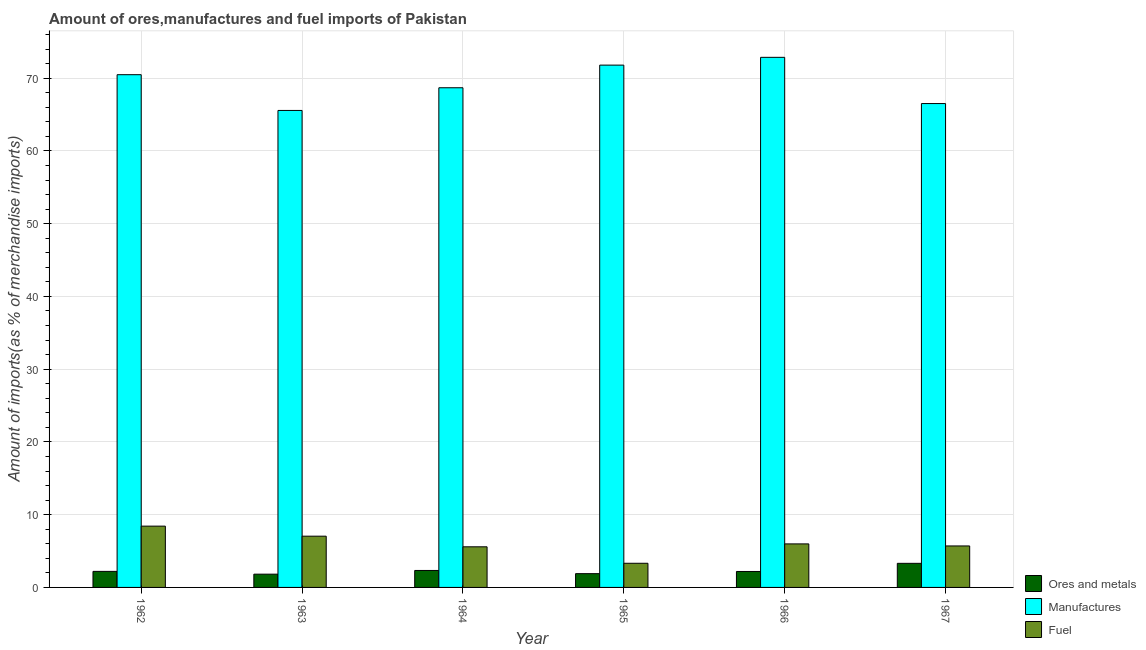How many groups of bars are there?
Your response must be concise. 6. Are the number of bars on each tick of the X-axis equal?
Your response must be concise. Yes. How many bars are there on the 2nd tick from the left?
Keep it short and to the point. 3. What is the label of the 6th group of bars from the left?
Provide a succinct answer. 1967. What is the percentage of ores and metals imports in 1967?
Offer a very short reply. 3.31. Across all years, what is the maximum percentage of fuel imports?
Offer a very short reply. 8.43. Across all years, what is the minimum percentage of ores and metals imports?
Provide a short and direct response. 1.82. In which year was the percentage of manufactures imports maximum?
Offer a terse response. 1966. What is the total percentage of ores and metals imports in the graph?
Offer a very short reply. 13.76. What is the difference between the percentage of manufactures imports in 1964 and that in 1966?
Provide a succinct answer. -4.18. What is the difference between the percentage of manufactures imports in 1963 and the percentage of ores and metals imports in 1966?
Your answer should be compact. -7.3. What is the average percentage of ores and metals imports per year?
Provide a succinct answer. 2.29. In how many years, is the percentage of ores and metals imports greater than 30 %?
Provide a short and direct response. 0. What is the ratio of the percentage of manufactures imports in 1964 to that in 1966?
Provide a short and direct response. 0.94. Is the percentage of fuel imports in 1966 less than that in 1967?
Your answer should be compact. No. What is the difference between the highest and the second highest percentage of manufactures imports?
Keep it short and to the point. 1.07. What is the difference between the highest and the lowest percentage of manufactures imports?
Your answer should be compact. 7.3. What does the 2nd bar from the left in 1963 represents?
Keep it short and to the point. Manufactures. What does the 1st bar from the right in 1963 represents?
Offer a terse response. Fuel. Is it the case that in every year, the sum of the percentage of ores and metals imports and percentage of manufactures imports is greater than the percentage of fuel imports?
Provide a short and direct response. Yes. Are all the bars in the graph horizontal?
Offer a very short reply. No. How many years are there in the graph?
Your answer should be compact. 6. Are the values on the major ticks of Y-axis written in scientific E-notation?
Provide a short and direct response. No. Does the graph contain any zero values?
Your answer should be compact. No. How are the legend labels stacked?
Your response must be concise. Vertical. What is the title of the graph?
Provide a short and direct response. Amount of ores,manufactures and fuel imports of Pakistan. Does "Domestic" appear as one of the legend labels in the graph?
Your response must be concise. No. What is the label or title of the Y-axis?
Your answer should be very brief. Amount of imports(as % of merchandise imports). What is the Amount of imports(as % of merchandise imports) in Ores and metals in 1962?
Offer a very short reply. 2.21. What is the Amount of imports(as % of merchandise imports) in Manufactures in 1962?
Make the answer very short. 70.48. What is the Amount of imports(as % of merchandise imports) of Fuel in 1962?
Your response must be concise. 8.43. What is the Amount of imports(as % of merchandise imports) of Ores and metals in 1963?
Your answer should be very brief. 1.82. What is the Amount of imports(as % of merchandise imports) of Manufactures in 1963?
Make the answer very short. 65.57. What is the Amount of imports(as % of merchandise imports) of Fuel in 1963?
Your response must be concise. 7.04. What is the Amount of imports(as % of merchandise imports) in Ores and metals in 1964?
Make the answer very short. 2.33. What is the Amount of imports(as % of merchandise imports) in Manufactures in 1964?
Make the answer very short. 68.68. What is the Amount of imports(as % of merchandise imports) in Fuel in 1964?
Make the answer very short. 5.58. What is the Amount of imports(as % of merchandise imports) of Ores and metals in 1965?
Your answer should be very brief. 1.89. What is the Amount of imports(as % of merchandise imports) of Manufactures in 1965?
Your response must be concise. 71.79. What is the Amount of imports(as % of merchandise imports) of Fuel in 1965?
Give a very brief answer. 3.32. What is the Amount of imports(as % of merchandise imports) of Ores and metals in 1966?
Your answer should be compact. 2.19. What is the Amount of imports(as % of merchandise imports) in Manufactures in 1966?
Offer a very short reply. 72.87. What is the Amount of imports(as % of merchandise imports) of Fuel in 1966?
Offer a terse response. 5.98. What is the Amount of imports(as % of merchandise imports) of Ores and metals in 1967?
Your response must be concise. 3.31. What is the Amount of imports(as % of merchandise imports) in Manufactures in 1967?
Your answer should be compact. 66.51. What is the Amount of imports(as % of merchandise imports) of Fuel in 1967?
Your answer should be very brief. 5.7. Across all years, what is the maximum Amount of imports(as % of merchandise imports) of Ores and metals?
Ensure brevity in your answer.  3.31. Across all years, what is the maximum Amount of imports(as % of merchandise imports) of Manufactures?
Make the answer very short. 72.87. Across all years, what is the maximum Amount of imports(as % of merchandise imports) in Fuel?
Your answer should be compact. 8.43. Across all years, what is the minimum Amount of imports(as % of merchandise imports) of Ores and metals?
Offer a very short reply. 1.82. Across all years, what is the minimum Amount of imports(as % of merchandise imports) in Manufactures?
Give a very brief answer. 65.57. Across all years, what is the minimum Amount of imports(as % of merchandise imports) in Fuel?
Your answer should be compact. 3.32. What is the total Amount of imports(as % of merchandise imports) in Ores and metals in the graph?
Offer a terse response. 13.76. What is the total Amount of imports(as % of merchandise imports) of Manufactures in the graph?
Provide a short and direct response. 415.9. What is the total Amount of imports(as % of merchandise imports) of Fuel in the graph?
Offer a very short reply. 36.06. What is the difference between the Amount of imports(as % of merchandise imports) in Ores and metals in 1962 and that in 1963?
Keep it short and to the point. 0.38. What is the difference between the Amount of imports(as % of merchandise imports) in Manufactures in 1962 and that in 1963?
Make the answer very short. 4.91. What is the difference between the Amount of imports(as % of merchandise imports) in Fuel in 1962 and that in 1963?
Provide a short and direct response. 1.38. What is the difference between the Amount of imports(as % of merchandise imports) in Ores and metals in 1962 and that in 1964?
Give a very brief answer. -0.13. What is the difference between the Amount of imports(as % of merchandise imports) of Manufactures in 1962 and that in 1964?
Your answer should be very brief. 1.8. What is the difference between the Amount of imports(as % of merchandise imports) of Fuel in 1962 and that in 1964?
Offer a very short reply. 2.84. What is the difference between the Amount of imports(as % of merchandise imports) of Ores and metals in 1962 and that in 1965?
Your answer should be very brief. 0.31. What is the difference between the Amount of imports(as % of merchandise imports) in Manufactures in 1962 and that in 1965?
Give a very brief answer. -1.32. What is the difference between the Amount of imports(as % of merchandise imports) of Fuel in 1962 and that in 1965?
Ensure brevity in your answer.  5.11. What is the difference between the Amount of imports(as % of merchandise imports) of Ores and metals in 1962 and that in 1966?
Your answer should be very brief. 0.01. What is the difference between the Amount of imports(as % of merchandise imports) of Manufactures in 1962 and that in 1966?
Give a very brief answer. -2.39. What is the difference between the Amount of imports(as % of merchandise imports) of Fuel in 1962 and that in 1966?
Offer a very short reply. 2.44. What is the difference between the Amount of imports(as % of merchandise imports) in Ores and metals in 1962 and that in 1967?
Your answer should be very brief. -1.11. What is the difference between the Amount of imports(as % of merchandise imports) in Manufactures in 1962 and that in 1967?
Your answer should be very brief. 3.97. What is the difference between the Amount of imports(as % of merchandise imports) of Fuel in 1962 and that in 1967?
Provide a short and direct response. 2.72. What is the difference between the Amount of imports(as % of merchandise imports) of Ores and metals in 1963 and that in 1964?
Your response must be concise. -0.51. What is the difference between the Amount of imports(as % of merchandise imports) of Manufactures in 1963 and that in 1964?
Offer a very short reply. -3.12. What is the difference between the Amount of imports(as % of merchandise imports) in Fuel in 1963 and that in 1964?
Give a very brief answer. 1.46. What is the difference between the Amount of imports(as % of merchandise imports) in Ores and metals in 1963 and that in 1965?
Your answer should be compact. -0.07. What is the difference between the Amount of imports(as % of merchandise imports) in Manufactures in 1963 and that in 1965?
Your response must be concise. -6.23. What is the difference between the Amount of imports(as % of merchandise imports) of Fuel in 1963 and that in 1965?
Provide a short and direct response. 3.73. What is the difference between the Amount of imports(as % of merchandise imports) in Ores and metals in 1963 and that in 1966?
Keep it short and to the point. -0.37. What is the difference between the Amount of imports(as % of merchandise imports) of Manufactures in 1963 and that in 1966?
Keep it short and to the point. -7.3. What is the difference between the Amount of imports(as % of merchandise imports) of Fuel in 1963 and that in 1966?
Your response must be concise. 1.06. What is the difference between the Amount of imports(as % of merchandise imports) of Ores and metals in 1963 and that in 1967?
Keep it short and to the point. -1.49. What is the difference between the Amount of imports(as % of merchandise imports) in Manufactures in 1963 and that in 1967?
Provide a succinct answer. -0.95. What is the difference between the Amount of imports(as % of merchandise imports) of Fuel in 1963 and that in 1967?
Offer a terse response. 1.34. What is the difference between the Amount of imports(as % of merchandise imports) of Ores and metals in 1964 and that in 1965?
Offer a terse response. 0.44. What is the difference between the Amount of imports(as % of merchandise imports) of Manufactures in 1964 and that in 1965?
Make the answer very short. -3.11. What is the difference between the Amount of imports(as % of merchandise imports) in Fuel in 1964 and that in 1965?
Keep it short and to the point. 2.26. What is the difference between the Amount of imports(as % of merchandise imports) of Ores and metals in 1964 and that in 1966?
Make the answer very short. 0.14. What is the difference between the Amount of imports(as % of merchandise imports) in Manufactures in 1964 and that in 1966?
Make the answer very short. -4.18. What is the difference between the Amount of imports(as % of merchandise imports) in Fuel in 1964 and that in 1966?
Your answer should be compact. -0.4. What is the difference between the Amount of imports(as % of merchandise imports) of Ores and metals in 1964 and that in 1967?
Keep it short and to the point. -0.98. What is the difference between the Amount of imports(as % of merchandise imports) of Manufactures in 1964 and that in 1967?
Your answer should be compact. 2.17. What is the difference between the Amount of imports(as % of merchandise imports) in Fuel in 1964 and that in 1967?
Your response must be concise. -0.12. What is the difference between the Amount of imports(as % of merchandise imports) in Ores and metals in 1965 and that in 1966?
Offer a very short reply. -0.3. What is the difference between the Amount of imports(as % of merchandise imports) of Manufactures in 1965 and that in 1966?
Provide a short and direct response. -1.07. What is the difference between the Amount of imports(as % of merchandise imports) in Fuel in 1965 and that in 1966?
Keep it short and to the point. -2.66. What is the difference between the Amount of imports(as % of merchandise imports) of Ores and metals in 1965 and that in 1967?
Your answer should be compact. -1.42. What is the difference between the Amount of imports(as % of merchandise imports) of Manufactures in 1965 and that in 1967?
Your answer should be compact. 5.28. What is the difference between the Amount of imports(as % of merchandise imports) of Fuel in 1965 and that in 1967?
Make the answer very short. -2.38. What is the difference between the Amount of imports(as % of merchandise imports) in Ores and metals in 1966 and that in 1967?
Your response must be concise. -1.12. What is the difference between the Amount of imports(as % of merchandise imports) of Manufactures in 1966 and that in 1967?
Ensure brevity in your answer.  6.35. What is the difference between the Amount of imports(as % of merchandise imports) in Fuel in 1966 and that in 1967?
Provide a short and direct response. 0.28. What is the difference between the Amount of imports(as % of merchandise imports) in Ores and metals in 1962 and the Amount of imports(as % of merchandise imports) in Manufactures in 1963?
Your answer should be compact. -63.36. What is the difference between the Amount of imports(as % of merchandise imports) in Ores and metals in 1962 and the Amount of imports(as % of merchandise imports) in Fuel in 1963?
Provide a succinct answer. -4.84. What is the difference between the Amount of imports(as % of merchandise imports) in Manufactures in 1962 and the Amount of imports(as % of merchandise imports) in Fuel in 1963?
Provide a short and direct response. 63.44. What is the difference between the Amount of imports(as % of merchandise imports) in Ores and metals in 1962 and the Amount of imports(as % of merchandise imports) in Manufactures in 1964?
Give a very brief answer. -66.48. What is the difference between the Amount of imports(as % of merchandise imports) in Ores and metals in 1962 and the Amount of imports(as % of merchandise imports) in Fuel in 1964?
Offer a very short reply. -3.38. What is the difference between the Amount of imports(as % of merchandise imports) of Manufactures in 1962 and the Amount of imports(as % of merchandise imports) of Fuel in 1964?
Keep it short and to the point. 64.9. What is the difference between the Amount of imports(as % of merchandise imports) of Ores and metals in 1962 and the Amount of imports(as % of merchandise imports) of Manufactures in 1965?
Provide a succinct answer. -69.59. What is the difference between the Amount of imports(as % of merchandise imports) in Ores and metals in 1962 and the Amount of imports(as % of merchandise imports) in Fuel in 1965?
Provide a short and direct response. -1.11. What is the difference between the Amount of imports(as % of merchandise imports) in Manufactures in 1962 and the Amount of imports(as % of merchandise imports) in Fuel in 1965?
Your answer should be very brief. 67.16. What is the difference between the Amount of imports(as % of merchandise imports) in Ores and metals in 1962 and the Amount of imports(as % of merchandise imports) in Manufactures in 1966?
Offer a very short reply. -70.66. What is the difference between the Amount of imports(as % of merchandise imports) of Ores and metals in 1962 and the Amount of imports(as % of merchandise imports) of Fuel in 1966?
Ensure brevity in your answer.  -3.78. What is the difference between the Amount of imports(as % of merchandise imports) in Manufactures in 1962 and the Amount of imports(as % of merchandise imports) in Fuel in 1966?
Ensure brevity in your answer.  64.5. What is the difference between the Amount of imports(as % of merchandise imports) in Ores and metals in 1962 and the Amount of imports(as % of merchandise imports) in Manufactures in 1967?
Your answer should be very brief. -64.31. What is the difference between the Amount of imports(as % of merchandise imports) in Ores and metals in 1962 and the Amount of imports(as % of merchandise imports) in Fuel in 1967?
Make the answer very short. -3.5. What is the difference between the Amount of imports(as % of merchandise imports) of Manufactures in 1962 and the Amount of imports(as % of merchandise imports) of Fuel in 1967?
Give a very brief answer. 64.78. What is the difference between the Amount of imports(as % of merchandise imports) of Ores and metals in 1963 and the Amount of imports(as % of merchandise imports) of Manufactures in 1964?
Give a very brief answer. -66.86. What is the difference between the Amount of imports(as % of merchandise imports) of Ores and metals in 1963 and the Amount of imports(as % of merchandise imports) of Fuel in 1964?
Offer a very short reply. -3.76. What is the difference between the Amount of imports(as % of merchandise imports) of Manufactures in 1963 and the Amount of imports(as % of merchandise imports) of Fuel in 1964?
Your answer should be compact. 59.98. What is the difference between the Amount of imports(as % of merchandise imports) of Ores and metals in 1963 and the Amount of imports(as % of merchandise imports) of Manufactures in 1965?
Give a very brief answer. -69.97. What is the difference between the Amount of imports(as % of merchandise imports) in Ores and metals in 1963 and the Amount of imports(as % of merchandise imports) in Fuel in 1965?
Give a very brief answer. -1.5. What is the difference between the Amount of imports(as % of merchandise imports) of Manufactures in 1963 and the Amount of imports(as % of merchandise imports) of Fuel in 1965?
Offer a very short reply. 62.25. What is the difference between the Amount of imports(as % of merchandise imports) of Ores and metals in 1963 and the Amount of imports(as % of merchandise imports) of Manufactures in 1966?
Your response must be concise. -71.04. What is the difference between the Amount of imports(as % of merchandise imports) of Ores and metals in 1963 and the Amount of imports(as % of merchandise imports) of Fuel in 1966?
Your answer should be compact. -4.16. What is the difference between the Amount of imports(as % of merchandise imports) of Manufactures in 1963 and the Amount of imports(as % of merchandise imports) of Fuel in 1966?
Your response must be concise. 59.58. What is the difference between the Amount of imports(as % of merchandise imports) of Ores and metals in 1963 and the Amount of imports(as % of merchandise imports) of Manufactures in 1967?
Your answer should be compact. -64.69. What is the difference between the Amount of imports(as % of merchandise imports) in Ores and metals in 1963 and the Amount of imports(as % of merchandise imports) in Fuel in 1967?
Your response must be concise. -3.88. What is the difference between the Amount of imports(as % of merchandise imports) of Manufactures in 1963 and the Amount of imports(as % of merchandise imports) of Fuel in 1967?
Your answer should be very brief. 59.86. What is the difference between the Amount of imports(as % of merchandise imports) of Ores and metals in 1964 and the Amount of imports(as % of merchandise imports) of Manufactures in 1965?
Offer a very short reply. -69.46. What is the difference between the Amount of imports(as % of merchandise imports) in Ores and metals in 1964 and the Amount of imports(as % of merchandise imports) in Fuel in 1965?
Offer a terse response. -0.99. What is the difference between the Amount of imports(as % of merchandise imports) of Manufactures in 1964 and the Amount of imports(as % of merchandise imports) of Fuel in 1965?
Offer a very short reply. 65.36. What is the difference between the Amount of imports(as % of merchandise imports) in Ores and metals in 1964 and the Amount of imports(as % of merchandise imports) in Manufactures in 1966?
Provide a succinct answer. -70.53. What is the difference between the Amount of imports(as % of merchandise imports) in Ores and metals in 1964 and the Amount of imports(as % of merchandise imports) in Fuel in 1966?
Your response must be concise. -3.65. What is the difference between the Amount of imports(as % of merchandise imports) in Manufactures in 1964 and the Amount of imports(as % of merchandise imports) in Fuel in 1966?
Make the answer very short. 62.7. What is the difference between the Amount of imports(as % of merchandise imports) of Ores and metals in 1964 and the Amount of imports(as % of merchandise imports) of Manufactures in 1967?
Provide a succinct answer. -64.18. What is the difference between the Amount of imports(as % of merchandise imports) of Ores and metals in 1964 and the Amount of imports(as % of merchandise imports) of Fuel in 1967?
Your response must be concise. -3.37. What is the difference between the Amount of imports(as % of merchandise imports) in Manufactures in 1964 and the Amount of imports(as % of merchandise imports) in Fuel in 1967?
Give a very brief answer. 62.98. What is the difference between the Amount of imports(as % of merchandise imports) of Ores and metals in 1965 and the Amount of imports(as % of merchandise imports) of Manufactures in 1966?
Offer a terse response. -70.97. What is the difference between the Amount of imports(as % of merchandise imports) of Ores and metals in 1965 and the Amount of imports(as % of merchandise imports) of Fuel in 1966?
Keep it short and to the point. -4.09. What is the difference between the Amount of imports(as % of merchandise imports) in Manufactures in 1965 and the Amount of imports(as % of merchandise imports) in Fuel in 1966?
Your response must be concise. 65.81. What is the difference between the Amount of imports(as % of merchandise imports) in Ores and metals in 1965 and the Amount of imports(as % of merchandise imports) in Manufactures in 1967?
Offer a terse response. -64.62. What is the difference between the Amount of imports(as % of merchandise imports) of Ores and metals in 1965 and the Amount of imports(as % of merchandise imports) of Fuel in 1967?
Make the answer very short. -3.81. What is the difference between the Amount of imports(as % of merchandise imports) of Manufactures in 1965 and the Amount of imports(as % of merchandise imports) of Fuel in 1967?
Keep it short and to the point. 66.09. What is the difference between the Amount of imports(as % of merchandise imports) in Ores and metals in 1966 and the Amount of imports(as % of merchandise imports) in Manufactures in 1967?
Give a very brief answer. -64.32. What is the difference between the Amount of imports(as % of merchandise imports) in Ores and metals in 1966 and the Amount of imports(as % of merchandise imports) in Fuel in 1967?
Ensure brevity in your answer.  -3.51. What is the difference between the Amount of imports(as % of merchandise imports) of Manufactures in 1966 and the Amount of imports(as % of merchandise imports) of Fuel in 1967?
Keep it short and to the point. 67.16. What is the average Amount of imports(as % of merchandise imports) of Ores and metals per year?
Provide a succinct answer. 2.29. What is the average Amount of imports(as % of merchandise imports) of Manufactures per year?
Your response must be concise. 69.32. What is the average Amount of imports(as % of merchandise imports) of Fuel per year?
Keep it short and to the point. 6.01. In the year 1962, what is the difference between the Amount of imports(as % of merchandise imports) in Ores and metals and Amount of imports(as % of merchandise imports) in Manufactures?
Ensure brevity in your answer.  -68.27. In the year 1962, what is the difference between the Amount of imports(as % of merchandise imports) in Ores and metals and Amount of imports(as % of merchandise imports) in Fuel?
Ensure brevity in your answer.  -6.22. In the year 1962, what is the difference between the Amount of imports(as % of merchandise imports) of Manufactures and Amount of imports(as % of merchandise imports) of Fuel?
Make the answer very short. 62.05. In the year 1963, what is the difference between the Amount of imports(as % of merchandise imports) of Ores and metals and Amount of imports(as % of merchandise imports) of Manufactures?
Your response must be concise. -63.74. In the year 1963, what is the difference between the Amount of imports(as % of merchandise imports) of Ores and metals and Amount of imports(as % of merchandise imports) of Fuel?
Your response must be concise. -5.22. In the year 1963, what is the difference between the Amount of imports(as % of merchandise imports) of Manufactures and Amount of imports(as % of merchandise imports) of Fuel?
Your answer should be compact. 58.52. In the year 1964, what is the difference between the Amount of imports(as % of merchandise imports) of Ores and metals and Amount of imports(as % of merchandise imports) of Manufactures?
Your answer should be compact. -66.35. In the year 1964, what is the difference between the Amount of imports(as % of merchandise imports) of Ores and metals and Amount of imports(as % of merchandise imports) of Fuel?
Keep it short and to the point. -3.25. In the year 1964, what is the difference between the Amount of imports(as % of merchandise imports) of Manufactures and Amount of imports(as % of merchandise imports) of Fuel?
Offer a very short reply. 63.1. In the year 1965, what is the difference between the Amount of imports(as % of merchandise imports) in Ores and metals and Amount of imports(as % of merchandise imports) in Manufactures?
Give a very brief answer. -69.9. In the year 1965, what is the difference between the Amount of imports(as % of merchandise imports) in Ores and metals and Amount of imports(as % of merchandise imports) in Fuel?
Your response must be concise. -1.43. In the year 1965, what is the difference between the Amount of imports(as % of merchandise imports) of Manufactures and Amount of imports(as % of merchandise imports) of Fuel?
Give a very brief answer. 68.48. In the year 1966, what is the difference between the Amount of imports(as % of merchandise imports) in Ores and metals and Amount of imports(as % of merchandise imports) in Manufactures?
Your response must be concise. -70.67. In the year 1966, what is the difference between the Amount of imports(as % of merchandise imports) of Ores and metals and Amount of imports(as % of merchandise imports) of Fuel?
Your answer should be very brief. -3.79. In the year 1966, what is the difference between the Amount of imports(as % of merchandise imports) in Manufactures and Amount of imports(as % of merchandise imports) in Fuel?
Offer a very short reply. 66.88. In the year 1967, what is the difference between the Amount of imports(as % of merchandise imports) in Ores and metals and Amount of imports(as % of merchandise imports) in Manufactures?
Your answer should be very brief. -63.2. In the year 1967, what is the difference between the Amount of imports(as % of merchandise imports) in Ores and metals and Amount of imports(as % of merchandise imports) in Fuel?
Offer a very short reply. -2.39. In the year 1967, what is the difference between the Amount of imports(as % of merchandise imports) of Manufactures and Amount of imports(as % of merchandise imports) of Fuel?
Keep it short and to the point. 60.81. What is the ratio of the Amount of imports(as % of merchandise imports) in Ores and metals in 1962 to that in 1963?
Give a very brief answer. 1.21. What is the ratio of the Amount of imports(as % of merchandise imports) in Manufactures in 1962 to that in 1963?
Your answer should be compact. 1.07. What is the ratio of the Amount of imports(as % of merchandise imports) in Fuel in 1962 to that in 1963?
Provide a succinct answer. 1.2. What is the ratio of the Amount of imports(as % of merchandise imports) of Ores and metals in 1962 to that in 1964?
Give a very brief answer. 0.95. What is the ratio of the Amount of imports(as % of merchandise imports) in Manufactures in 1962 to that in 1964?
Your answer should be compact. 1.03. What is the ratio of the Amount of imports(as % of merchandise imports) of Fuel in 1962 to that in 1964?
Provide a succinct answer. 1.51. What is the ratio of the Amount of imports(as % of merchandise imports) in Ores and metals in 1962 to that in 1965?
Give a very brief answer. 1.17. What is the ratio of the Amount of imports(as % of merchandise imports) of Manufactures in 1962 to that in 1965?
Your response must be concise. 0.98. What is the ratio of the Amount of imports(as % of merchandise imports) of Fuel in 1962 to that in 1965?
Make the answer very short. 2.54. What is the ratio of the Amount of imports(as % of merchandise imports) of Ores and metals in 1962 to that in 1966?
Make the answer very short. 1.01. What is the ratio of the Amount of imports(as % of merchandise imports) of Manufactures in 1962 to that in 1966?
Ensure brevity in your answer.  0.97. What is the ratio of the Amount of imports(as % of merchandise imports) in Fuel in 1962 to that in 1966?
Offer a terse response. 1.41. What is the ratio of the Amount of imports(as % of merchandise imports) in Ores and metals in 1962 to that in 1967?
Offer a very short reply. 0.67. What is the ratio of the Amount of imports(as % of merchandise imports) in Manufactures in 1962 to that in 1967?
Your answer should be very brief. 1.06. What is the ratio of the Amount of imports(as % of merchandise imports) of Fuel in 1962 to that in 1967?
Make the answer very short. 1.48. What is the ratio of the Amount of imports(as % of merchandise imports) of Ores and metals in 1963 to that in 1964?
Provide a short and direct response. 0.78. What is the ratio of the Amount of imports(as % of merchandise imports) of Manufactures in 1963 to that in 1964?
Provide a short and direct response. 0.95. What is the ratio of the Amount of imports(as % of merchandise imports) of Fuel in 1963 to that in 1964?
Provide a short and direct response. 1.26. What is the ratio of the Amount of imports(as % of merchandise imports) of Ores and metals in 1963 to that in 1965?
Offer a very short reply. 0.96. What is the ratio of the Amount of imports(as % of merchandise imports) in Manufactures in 1963 to that in 1965?
Make the answer very short. 0.91. What is the ratio of the Amount of imports(as % of merchandise imports) in Fuel in 1963 to that in 1965?
Ensure brevity in your answer.  2.12. What is the ratio of the Amount of imports(as % of merchandise imports) of Ores and metals in 1963 to that in 1966?
Provide a short and direct response. 0.83. What is the ratio of the Amount of imports(as % of merchandise imports) of Manufactures in 1963 to that in 1966?
Your response must be concise. 0.9. What is the ratio of the Amount of imports(as % of merchandise imports) of Fuel in 1963 to that in 1966?
Offer a terse response. 1.18. What is the ratio of the Amount of imports(as % of merchandise imports) in Ores and metals in 1963 to that in 1967?
Make the answer very short. 0.55. What is the ratio of the Amount of imports(as % of merchandise imports) of Manufactures in 1963 to that in 1967?
Provide a succinct answer. 0.99. What is the ratio of the Amount of imports(as % of merchandise imports) of Fuel in 1963 to that in 1967?
Offer a very short reply. 1.24. What is the ratio of the Amount of imports(as % of merchandise imports) of Ores and metals in 1964 to that in 1965?
Ensure brevity in your answer.  1.23. What is the ratio of the Amount of imports(as % of merchandise imports) in Manufactures in 1964 to that in 1965?
Your response must be concise. 0.96. What is the ratio of the Amount of imports(as % of merchandise imports) in Fuel in 1964 to that in 1965?
Provide a succinct answer. 1.68. What is the ratio of the Amount of imports(as % of merchandise imports) of Ores and metals in 1964 to that in 1966?
Give a very brief answer. 1.06. What is the ratio of the Amount of imports(as % of merchandise imports) of Manufactures in 1964 to that in 1966?
Ensure brevity in your answer.  0.94. What is the ratio of the Amount of imports(as % of merchandise imports) in Fuel in 1964 to that in 1966?
Your answer should be compact. 0.93. What is the ratio of the Amount of imports(as % of merchandise imports) of Ores and metals in 1964 to that in 1967?
Offer a terse response. 0.7. What is the ratio of the Amount of imports(as % of merchandise imports) in Manufactures in 1964 to that in 1967?
Your response must be concise. 1.03. What is the ratio of the Amount of imports(as % of merchandise imports) in Fuel in 1964 to that in 1967?
Your answer should be very brief. 0.98. What is the ratio of the Amount of imports(as % of merchandise imports) of Ores and metals in 1965 to that in 1966?
Make the answer very short. 0.86. What is the ratio of the Amount of imports(as % of merchandise imports) in Fuel in 1965 to that in 1966?
Provide a short and direct response. 0.55. What is the ratio of the Amount of imports(as % of merchandise imports) of Ores and metals in 1965 to that in 1967?
Ensure brevity in your answer.  0.57. What is the ratio of the Amount of imports(as % of merchandise imports) in Manufactures in 1965 to that in 1967?
Give a very brief answer. 1.08. What is the ratio of the Amount of imports(as % of merchandise imports) in Fuel in 1965 to that in 1967?
Keep it short and to the point. 0.58. What is the ratio of the Amount of imports(as % of merchandise imports) of Ores and metals in 1966 to that in 1967?
Give a very brief answer. 0.66. What is the ratio of the Amount of imports(as % of merchandise imports) of Manufactures in 1966 to that in 1967?
Keep it short and to the point. 1.1. What is the ratio of the Amount of imports(as % of merchandise imports) in Fuel in 1966 to that in 1967?
Ensure brevity in your answer.  1.05. What is the difference between the highest and the second highest Amount of imports(as % of merchandise imports) of Ores and metals?
Give a very brief answer. 0.98. What is the difference between the highest and the second highest Amount of imports(as % of merchandise imports) in Manufactures?
Your answer should be very brief. 1.07. What is the difference between the highest and the second highest Amount of imports(as % of merchandise imports) of Fuel?
Your answer should be very brief. 1.38. What is the difference between the highest and the lowest Amount of imports(as % of merchandise imports) of Ores and metals?
Give a very brief answer. 1.49. What is the difference between the highest and the lowest Amount of imports(as % of merchandise imports) in Manufactures?
Your response must be concise. 7.3. What is the difference between the highest and the lowest Amount of imports(as % of merchandise imports) of Fuel?
Your response must be concise. 5.11. 